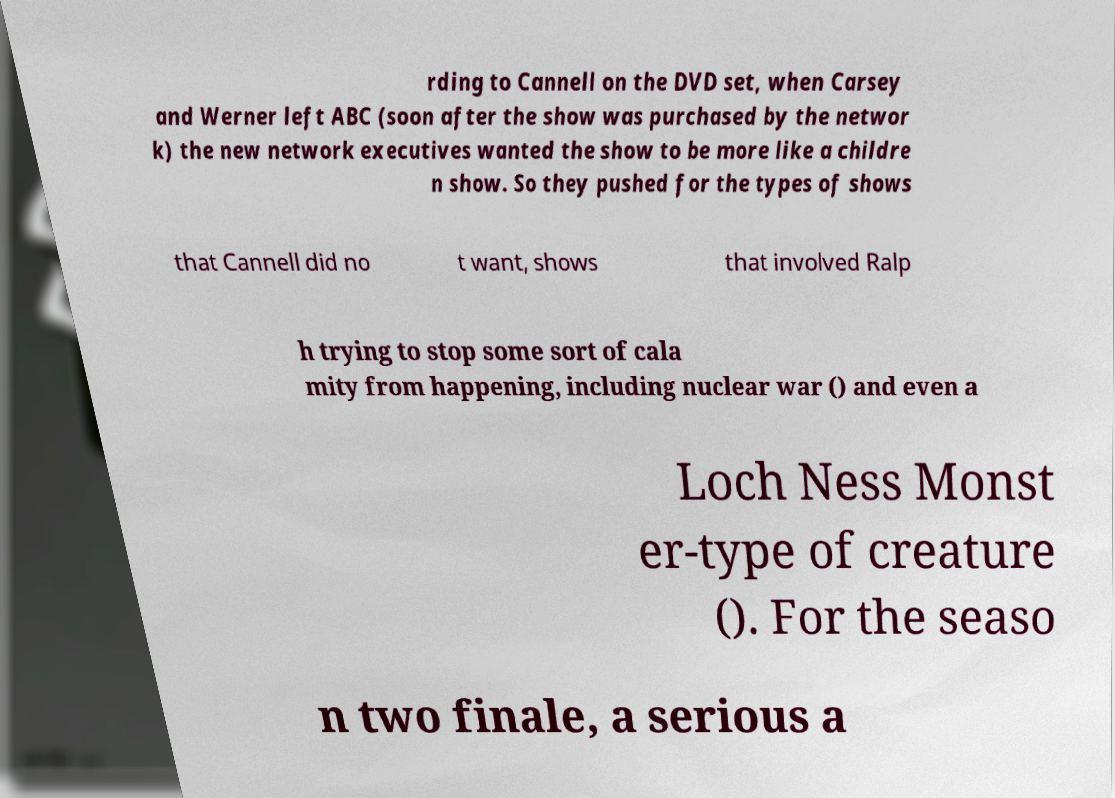I need the written content from this picture converted into text. Can you do that? rding to Cannell on the DVD set, when Carsey and Werner left ABC (soon after the show was purchased by the networ k) the new network executives wanted the show to be more like a childre n show. So they pushed for the types of shows that Cannell did no t want, shows that involved Ralp h trying to stop some sort of cala mity from happening, including nuclear war () and even a Loch Ness Monst er-type of creature (). For the seaso n two finale, a serious a 